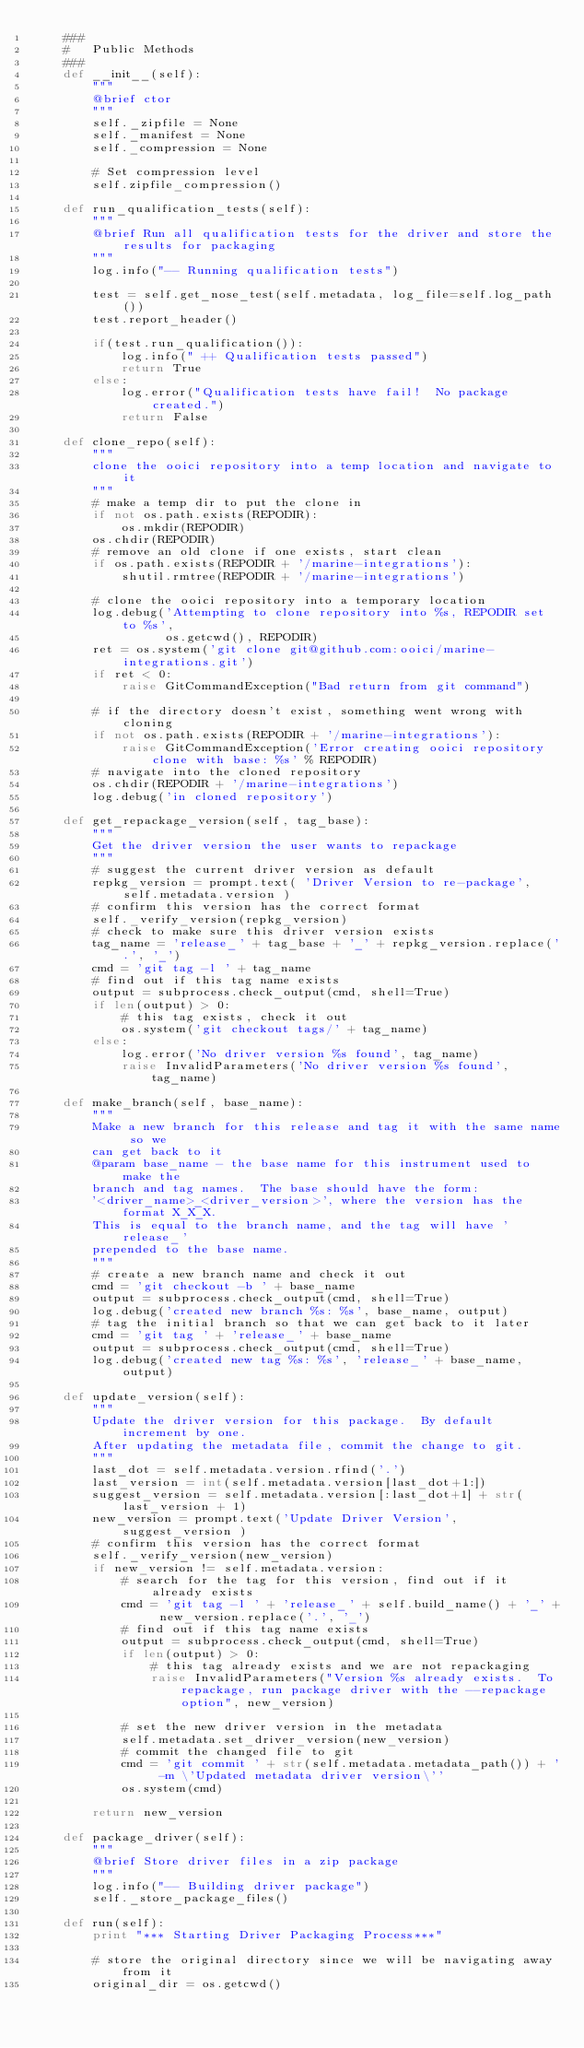Convert code to text. <code><loc_0><loc_0><loc_500><loc_500><_Python_>    ###
    #   Public Methods
    ###
    def __init__(self):
        """
        @brief ctor
        """
        self._zipfile = None
        self._manifest = None
        self._compression = None

        # Set compression level
        self.zipfile_compression()

    def run_qualification_tests(self):
        """
        @brief Run all qualification tests for the driver and store the results for packaging
        """
        log.info("-- Running qualification tests")

        test = self.get_nose_test(self.metadata, log_file=self.log_path())
        test.report_header()

        if(test.run_qualification()):
            log.info(" ++ Qualification tests passed")
            return True
        else:
            log.error("Qualification tests have fail!  No package created.")
            return False

    def clone_repo(self):
        """
        clone the ooici repository into a temp location and navigate to it
        """
        # make a temp dir to put the clone in
        if not os.path.exists(REPODIR):
            os.mkdir(REPODIR)
        os.chdir(REPODIR)
        # remove an old clone if one exists, start clean
        if os.path.exists(REPODIR + '/marine-integrations'):
            shutil.rmtree(REPODIR + '/marine-integrations')

        # clone the ooici repository into a temporary location
        log.debug('Attempting to clone repository into %s, REPODIR set to %s',
                  os.getcwd(), REPODIR)
        ret = os.system('git clone git@github.com:ooici/marine-integrations.git')
        if ret < 0:
            raise GitCommandException("Bad return from git command")

        # if the directory doesn't exist, something went wrong with cloning
        if not os.path.exists(REPODIR + '/marine-integrations'):
            raise GitCommandException('Error creating ooici repository clone with base: %s' % REPODIR)
        # navigate into the cloned repository
        os.chdir(REPODIR + '/marine-integrations')
        log.debug('in cloned repository')

    def get_repackage_version(self, tag_base):
        """
        Get the driver version the user wants to repackage
        """
        # suggest the current driver version as default
        repkg_version = prompt.text( 'Driver Version to re-package', self.metadata.version )
        # confirm this version has the correct format
        self._verify_version(repkg_version)
        # check to make sure this driver version exists
        tag_name = 'release_' + tag_base + '_' + repkg_version.replace('.', '_')
        cmd = 'git tag -l ' + tag_name
        # find out if this tag name exists
        output = subprocess.check_output(cmd, shell=True)
        if len(output) > 0:
            # this tag exists, check it out
            os.system('git checkout tags/' + tag_name)
        else:
            log.error('No driver version %s found', tag_name)
            raise InvalidParameters('No driver version %s found', tag_name)

    def make_branch(self, base_name):
        """
        Make a new branch for this release and tag it with the same name so we
        can get back to it
        @param base_name - the base name for this instrument used to make the
        branch and tag names.  The base should have the form:
        '<driver_name>_<driver_version>', where the version has the format X_X_X.
        This is equal to the branch name, and the tag will have 'release_'
        prepended to the base name.
        """
        # create a new branch name and check it out
        cmd = 'git checkout -b ' + base_name
        output = subprocess.check_output(cmd, shell=True)
        log.debug('created new branch %s: %s', base_name, output)
        # tag the initial branch so that we can get back to it later
        cmd = 'git tag ' + 'release_' + base_name
        output = subprocess.check_output(cmd, shell=True)
        log.debug('created new tag %s: %s', 'release_' + base_name, output)

    def update_version(self):
        """
        Update the driver version for this package.  By default increment by one.
        After updating the metadata file, commit the change to git.
        """
        last_dot = self.metadata.version.rfind('.')
        last_version = int(self.metadata.version[last_dot+1:])
        suggest_version = self.metadata.version[:last_dot+1] + str(last_version + 1)
        new_version = prompt.text('Update Driver Version', suggest_version )
        # confirm this version has the correct format
        self._verify_version(new_version)
        if new_version != self.metadata.version:
            # search for the tag for this version, find out if it already exists
            cmd = 'git tag -l ' + 'release_' + self.build_name() + '_' + new_version.replace('.', '_')
            # find out if this tag name exists
            output = subprocess.check_output(cmd, shell=True)
            if len(output) > 0:
                # this tag already exists and we are not repackaging
                raise InvalidParameters("Version %s already exists.  To repackage, run package driver with the --repackage option", new_version)

            # set the new driver version in the metadata
            self.metadata.set_driver_version(new_version)
            # commit the changed file to git
            cmd = 'git commit ' + str(self.metadata.metadata_path()) + ' -m \'Updated metadata driver version\''
            os.system(cmd)

        return new_version

    def package_driver(self):
        """
        @brief Store driver files in a zip package
        """
        log.info("-- Building driver package")
        self._store_package_files()

    def run(self):
        print "*** Starting Driver Packaging Process***"
        
        # store the original directory since we will be navigating away from it
        original_dir = os.getcwd()
</code> 